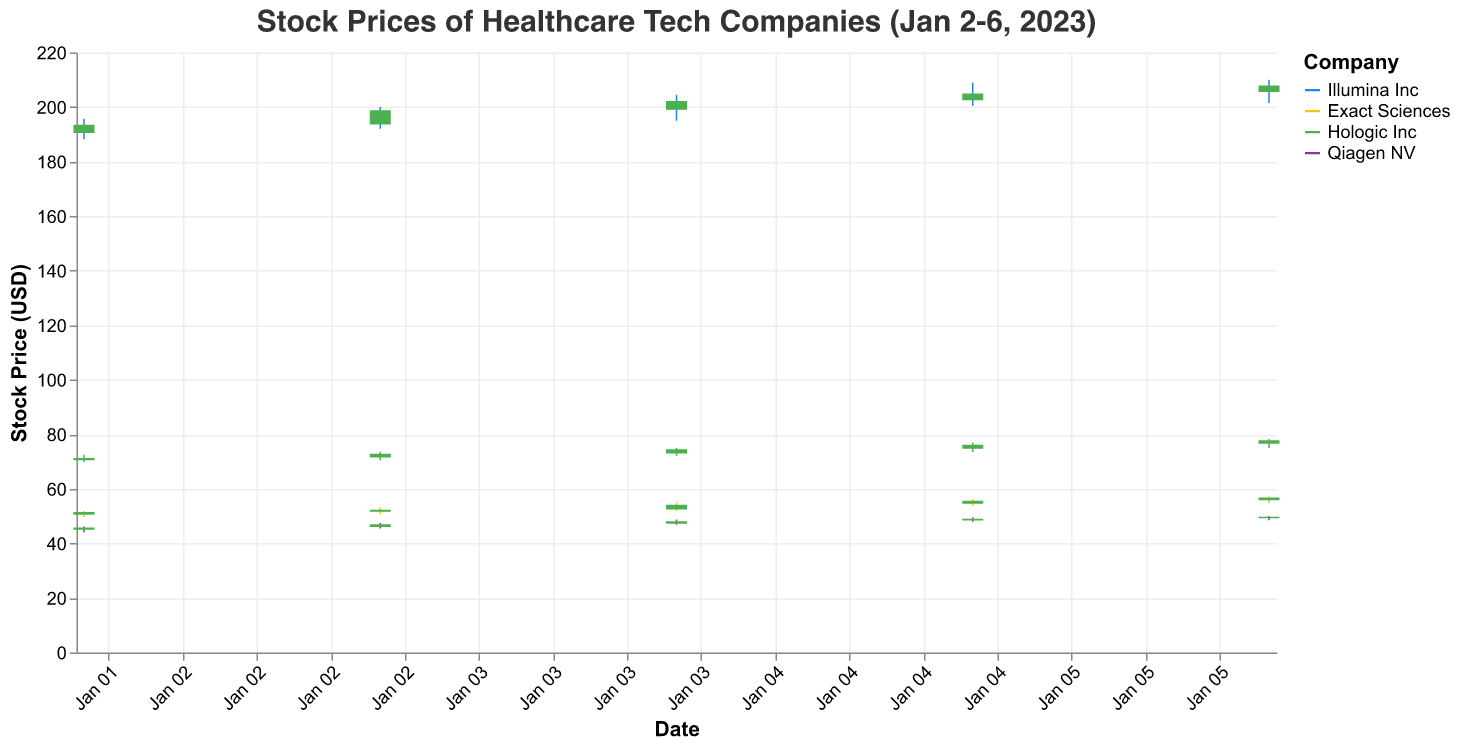What is the highest stock price for Illumina Inc on January 5, 2023? On January 5, 2023, the candlestick for Illumina Inc shows the highest point when looking at the High value. According to the data, the High price for Illumina Inc on this date is 209.00.
Answer: 209.00 Which company had the highest closing stock price on January 6, 2023? To find the highest closing stock price across companies on January 6, 2023, compare the Close prices for all companies on this date. Illumina Inc closed at 207.90, Exact Sciences at 56.80, Hologic Inc at 77.80, and Qiagen NV at 49.80. Illumina Inc had the highest closing price.
Answer: Illumina Inc What is the volume of shares traded for Qiagen NV on January 4, 2023? The tooltip information includes volume, specifying shares traded per day for each company. For Qiagen NV on January 4, 2023, the traded volume is 900,000 shares.
Answer: 900,000 Calculate the average opening price for Hologic Inc from January 2 to January 6, 2023. Sum the opening prices for Hologic Inc from January 2 to January 6 (70.50 + 71.50 + 73.00 + 74.70 + 76.50) and then divide by the number of days (5). This gives (70.50 + 71.50 + 73.00 + 74.70 + 76.50) / 5 = 73.24.
Answer: 73.24 Which company showed the greatest increase in closing price from January 2 to January 6, 2023? For each company, subtract the closing price on January 2 from the closing price on January 6. Illumina Inc increased by 207.90 - 193.50 = 14.40, Exact Sciences by 56.80 - 51.50 = 5.30, Hologic Inc by 77.80 - 71.30 = 6.50, and Qiagen NV by 49.80 - 45.80 = 4.00. Illumina Inc shows the greatest increase.
Answer: Illumina Inc How does the closing price of Exact Sciences on January 4 compare to its closing price on January 2? On January 2, Exact Sciences closed at 51.50. On January 4, it closed at 54.20. To compare, the closing price on January 4 is higher than on January 2.
Answer: Higher What is the range of high prices for Qiagen NV from January 2 to January 6, 2023? The range is calculated by subtracting the lowest high price from the highest high price over the period. High prices for Qiagen NV are 46.20, 47.50, 48.80, 49.50, and 50.00. The range is 50.00 - 46.20 = 3.80.
Answer: 3.80 Identify the company with the least variation in opening prices from January 2 to January 6, 2023. Variation can be determined by calculating the difference between the highest and lowest opening prices for each company. For Illumina Inc, the range is 205.50 - 190.50 = 15.00. For Exact Sciences, it's 55.80 - 50.50 = 5.30. For Hologic Inc, it's 76.50 - 70.50 = 6.00. For Qiagen NV, it's 49.20 - 45.00 = 4.20. Qiagen NV has the least variation.
Answer: Qiagen NV Which company's stock experienced the highest daily high price on January 5, 2023? On January 5, compare the High values of each company's stock: Illumina Inc (209.00), Exact Sciences (56.30), Hologic Inc (77.00), and Qiagen NV (49.50). Illumina Inc had the highest daily high price.
Answer: Illumina Inc 